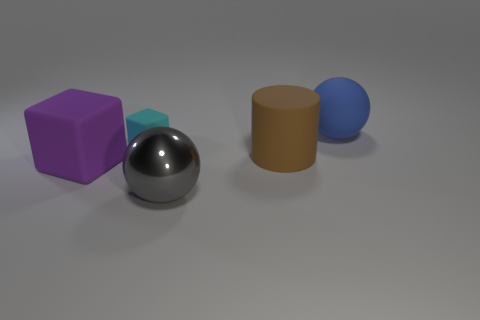Add 1 green spheres. How many objects exist? 6 Subtract all cubes. How many objects are left? 3 Add 1 large purple matte blocks. How many large purple matte blocks are left? 2 Add 3 yellow shiny spheres. How many yellow shiny spheres exist? 3 Subtract 0 blue cylinders. How many objects are left? 5 Subtract all large rubber cylinders. Subtract all brown matte spheres. How many objects are left? 4 